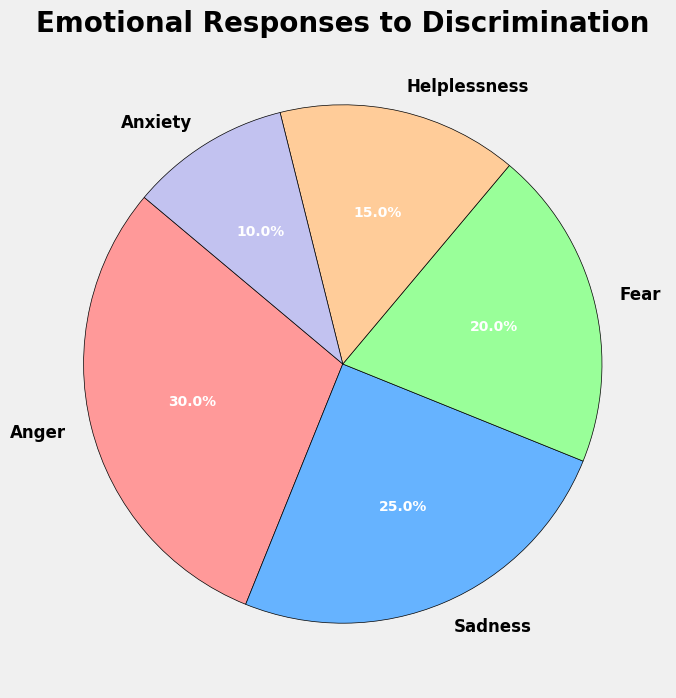What percentage of people feel anger? By looking at the pie chart segment labeled "Anger," we can see that it represents 30% of the total.
Answer: 30% Which emotion is felt by the smallest percentage of people? We can determine this by identifying the pie chart segment with the smallest slice, which is labeled "Anxiety" at 10%.
Answer: Anxiety What is the combined percentage of people who feel fear or helplessness? By adding the percentages for "Fear" and "Helplessness," we get 20% + 15% = 35%.
Answer: 35% Is there a higher percentage of people feeling sadness or anxiety? We compare the pie chart segments labeled "Sadness" and "Anxiety." Sadness is at 25%, whereas Anxiety is at 10%. Thus, sadness is higher.
Answer: Sadness What is the difference in percentage between those who feel anger and those who feel helplessness? By subtracting the percentage for "Helplessness" from "Anger," we get 30% - 15% = 15%.
Answer: 15% If we combine the percentages for those who feel sadness and anxiety, how does this compare to the percentage of those who feel anger? Adding the percentages for "Sadness" and "Anxiety" gives us 25% + 10% = 35%, which is greater than the 30% for "Anger."
Answer: 35% What percentage of people feel emotions other than anger? We can find this by subtracting the percentage for "Anger" from 100%, giving us 100% - 30% = 70%.
Answer: 70% Which two emotions combined account for the majority of the responses, and what is their combined percentage? Adding the two highest percentages, "Anger" and "Sadness," gives us 30% + 25% = 55%, which is more than 50%.
Answer: Anger and Sadness, 55% What is the average percentage of people feeling sadness, fear, and helplessness? Adding the percentages for "Sadness," "Fear," and "Helplessness" and dividing by 3 gives us (25% + 20% + 15%) / 3 = 20%.
Answer: 20% Is the percentage of people who feel sadness greater than those who feel fear and anxiety combined? Adding the percentages for "Fear" and "Anxiety" gives us 20% + 10% = 30%, which is greater than the 25% for "Sadness."
Answer: No 